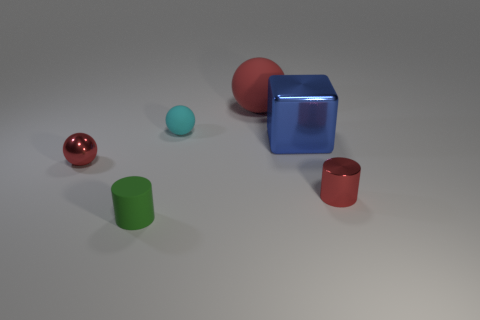Is the large matte ball the same color as the small matte cylinder?
Give a very brief answer. No. What is the shape of the small thing that is left of the shiny block and right of the small green thing?
Your answer should be compact. Sphere. Is there a metallic block that has the same color as the small shiny cylinder?
Provide a succinct answer. No. The cylinder that is behind the small cylinder left of the big blue object is what color?
Offer a terse response. Red. There is a green rubber object that is in front of the sphere that is to the right of the tiny matte thing that is behind the red metal cylinder; how big is it?
Offer a very short reply. Small. Is the small green object made of the same material as the tiny cylinder that is right of the rubber cylinder?
Provide a succinct answer. No. What is the size of the green cylinder that is the same material as the small cyan sphere?
Your answer should be very brief. Small. Are there any red metallic things that have the same shape as the large blue metallic thing?
Your answer should be compact. No. How many things are either metal things to the left of the big matte sphere or tiny matte cylinders?
Give a very brief answer. 2. There is a sphere that is the same color as the large matte object; what size is it?
Your answer should be compact. Small. 